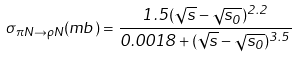<formula> <loc_0><loc_0><loc_500><loc_500>\sigma _ { \pi N \to \rho N } ( m b ) = \frac { 1 . 5 ( \sqrt { s } - \sqrt { s _ { 0 } } ) ^ { 2 . 2 } } { 0 . 0 0 1 8 + ( \sqrt { s } - \sqrt { s _ { 0 } } ) ^ { 3 . 5 } }</formula> 